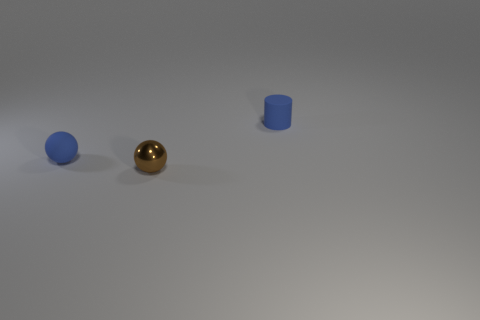The tiny brown thing is what shape?
Give a very brief answer. Sphere. What number of tiny brown matte spheres are there?
Offer a very short reply. 0. There is a tiny object in front of the blue rubber object in front of the small cylinder; what color is it?
Keep it short and to the point. Brown. There is a rubber cylinder that is the same size as the metal sphere; what color is it?
Make the answer very short. Blue. Are there any rubber spheres that have the same color as the cylinder?
Ensure brevity in your answer.  Yes. Are any metal objects visible?
Offer a very short reply. Yes. There is a small blue rubber object in front of the tiny cylinder; what is its shape?
Offer a very short reply. Sphere. How many rubber things are to the right of the tiny blue matte sphere and to the left of the tiny brown sphere?
Your response must be concise. 0. How many other things are the same size as the brown sphere?
Offer a very short reply. 2. There is a tiny thing that is in front of the matte sphere; does it have the same shape as the tiny matte thing that is on the right side of the brown shiny sphere?
Give a very brief answer. No. 